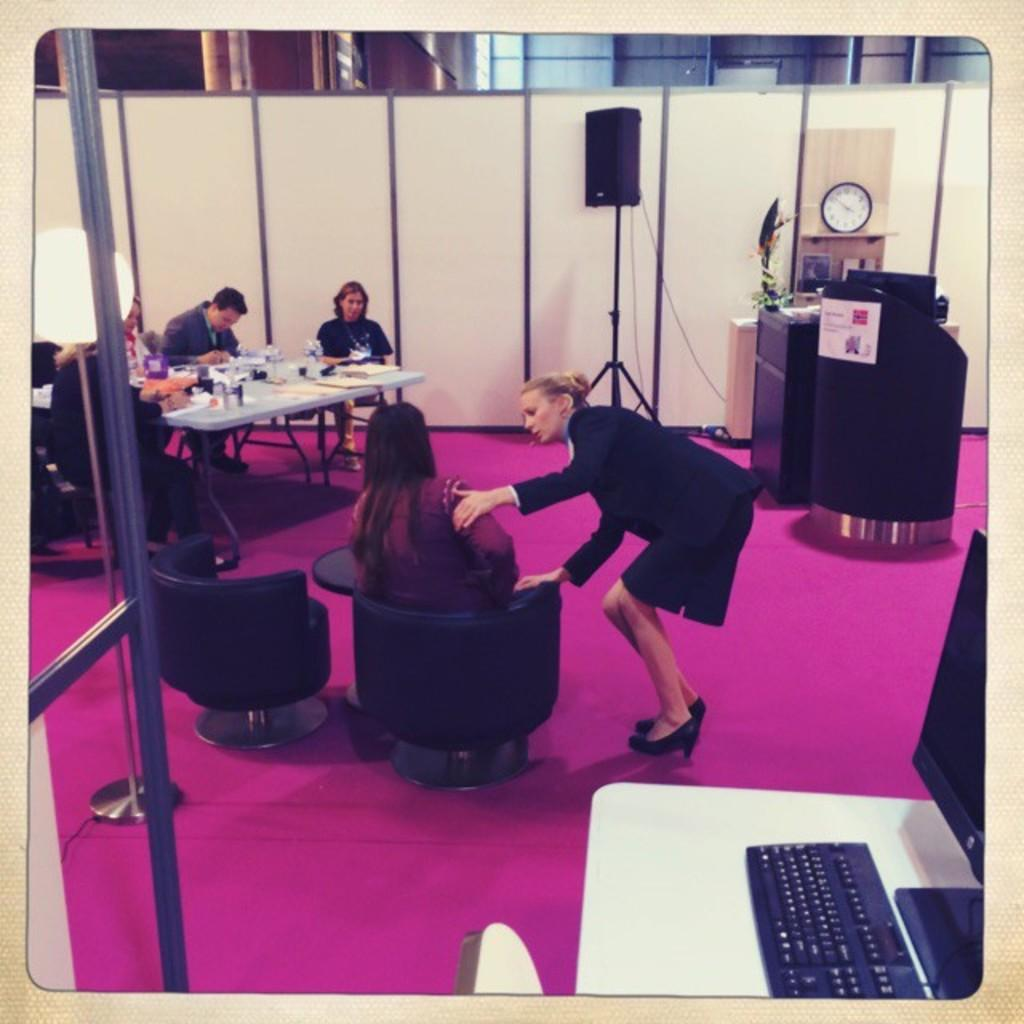What are the people in the image doing? The people in the image are sitting on chairs. Can you describe the woman in the image? There is a woman standing in the image. What is on the table in the image? There is a system and a keyboard on the table. Are there any other objects on the table? Yes, there are other objects on the table. What type of screw can be seen holding the square stick to the table in the image? There is no screw or square stick present in the image. 